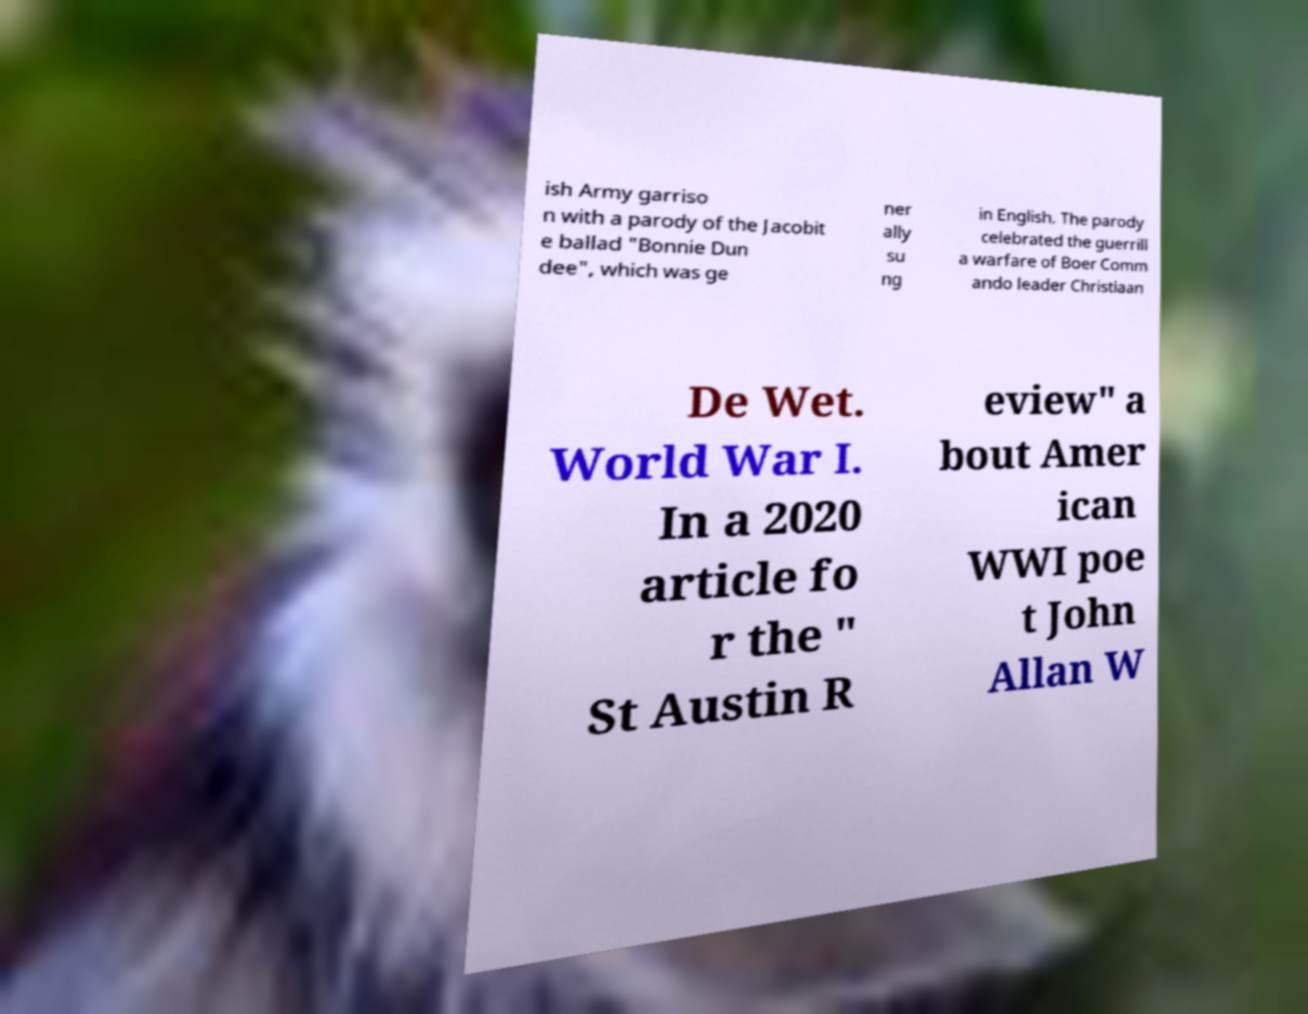I need the written content from this picture converted into text. Can you do that? ish Army garriso n with a parody of the Jacobit e ballad "Bonnie Dun dee", which was ge ner ally su ng in English. The parody celebrated the guerrill a warfare of Boer Comm ando leader Christiaan De Wet. World War I. In a 2020 article fo r the " St Austin R eview" a bout Amer ican WWI poe t John Allan W 